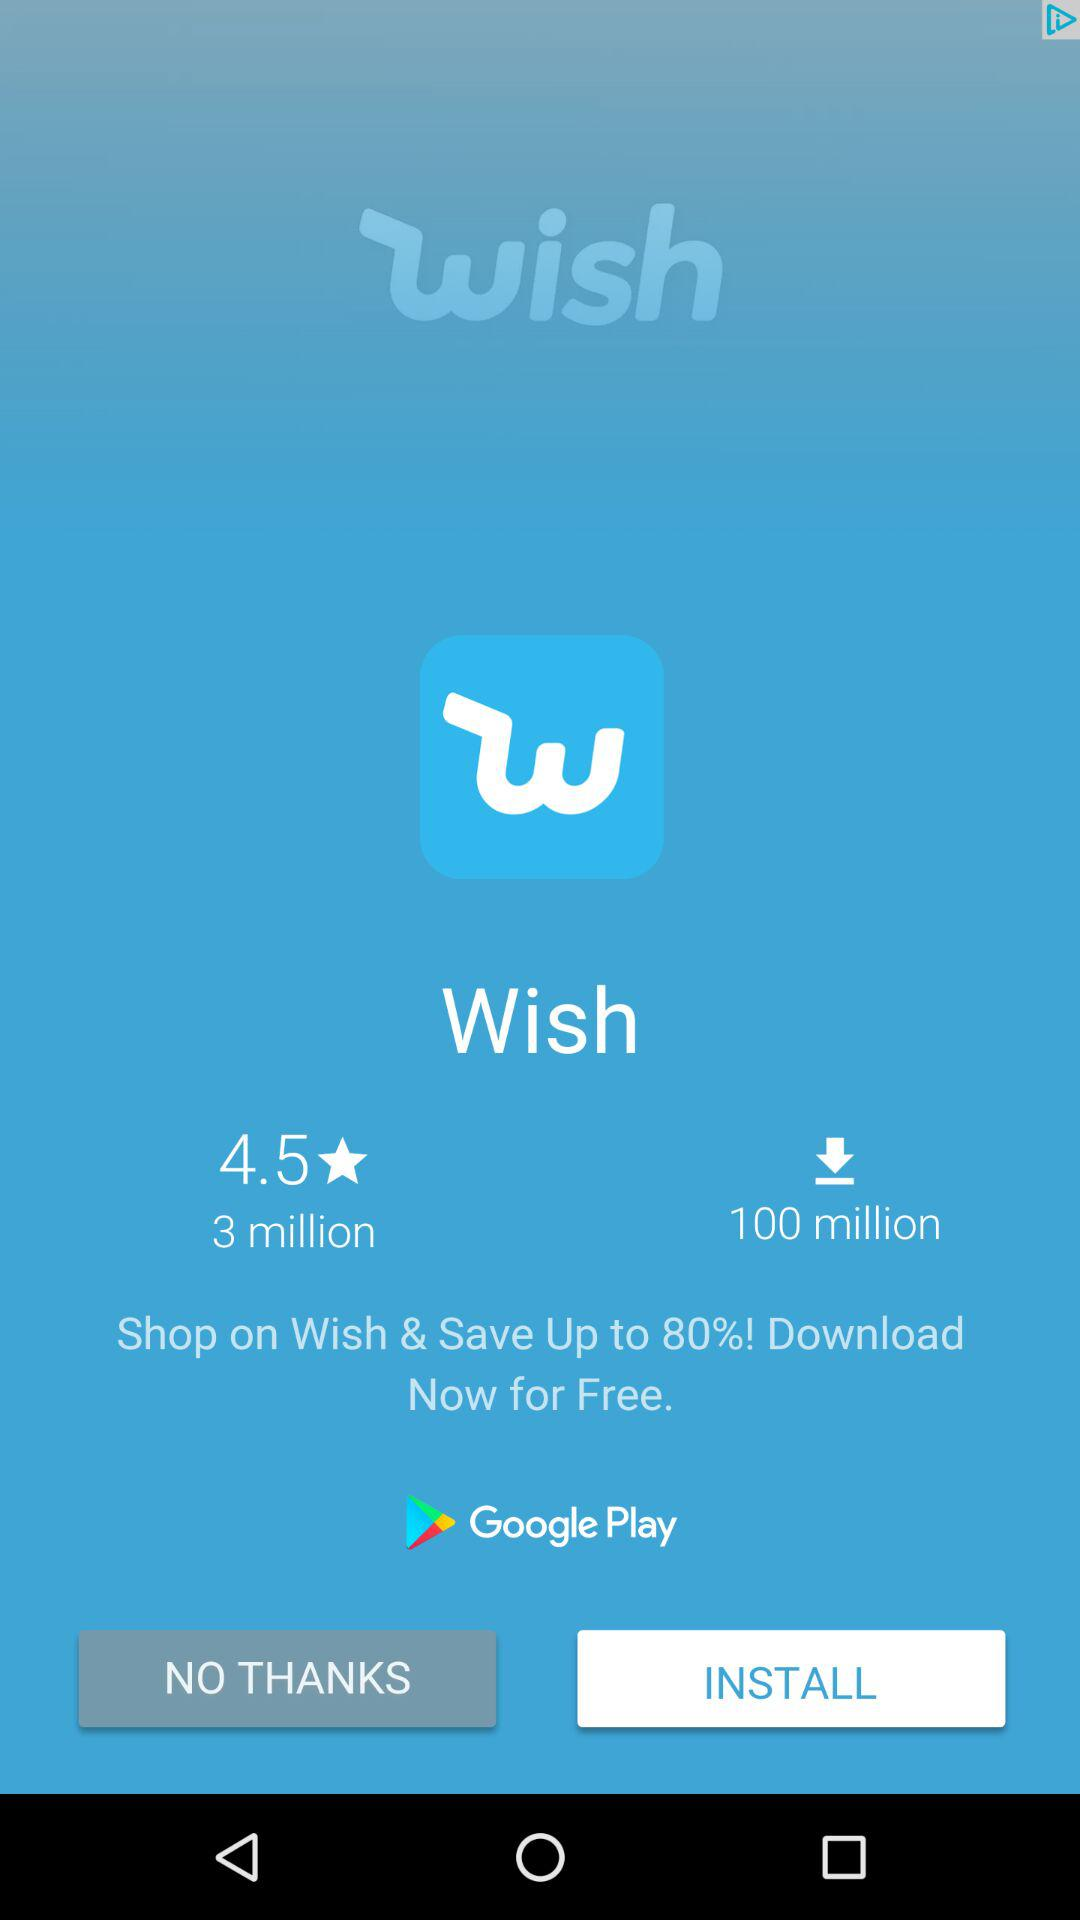How many more downloads does the Wish app have than the number of reviews?
Answer the question using a single word or phrase. 97 million 